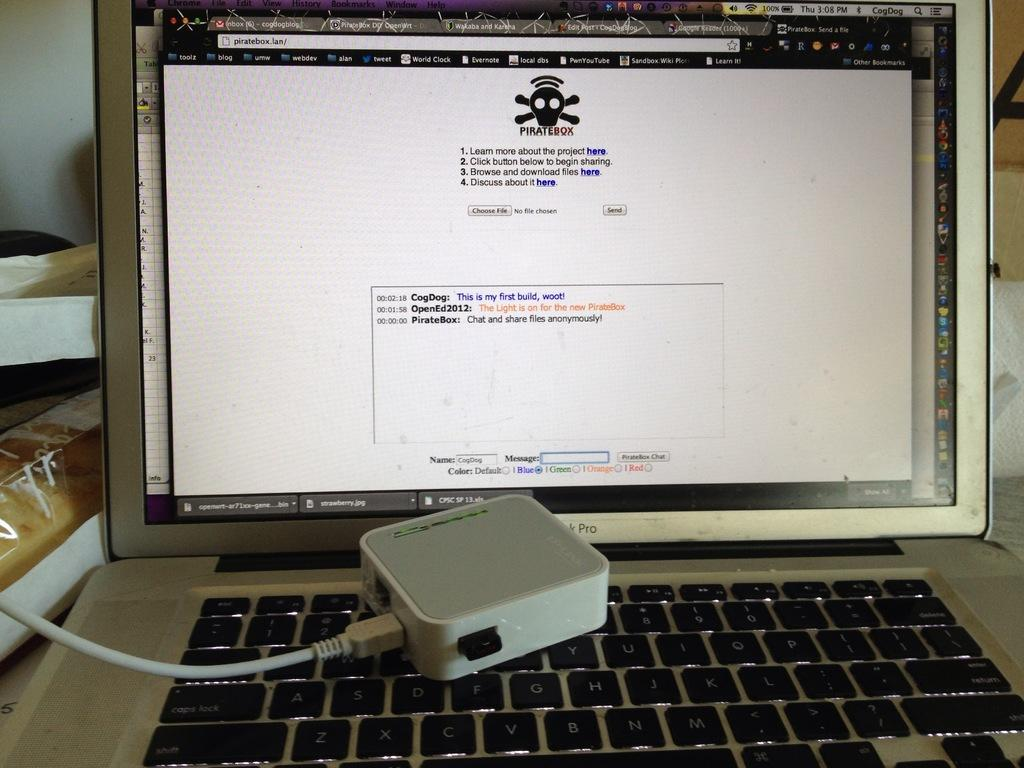<image>
Render a clear and concise summary of the photo. A computer has a web browser open to piratebox.lan. 